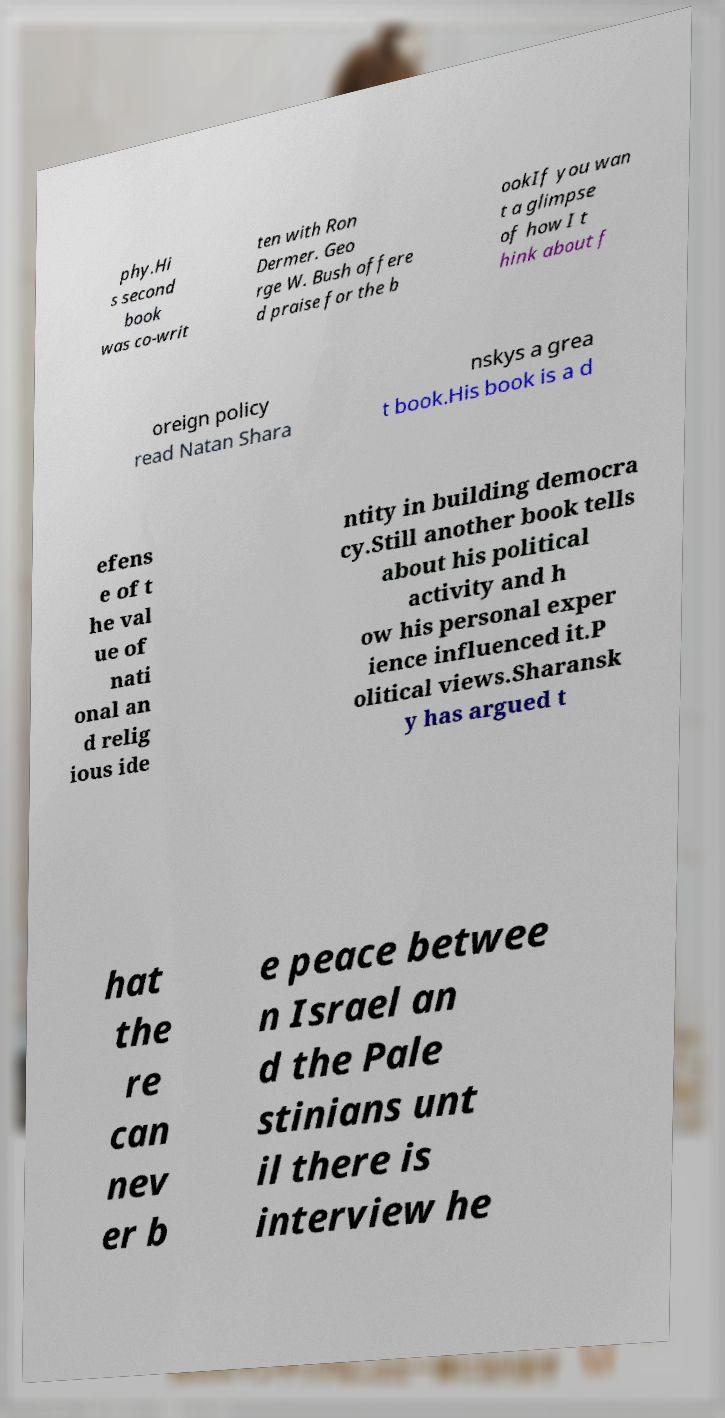Please read and relay the text visible in this image. What does it say? phy.Hi s second book was co-writ ten with Ron Dermer. Geo rge W. Bush offere d praise for the b ookIf you wan t a glimpse of how I t hink about f oreign policy read Natan Shara nskys a grea t book.His book is a d efens e of t he val ue of nati onal an d relig ious ide ntity in building democra cy.Still another book tells about his political activity and h ow his personal exper ience influenced it.P olitical views.Sharansk y has argued t hat the re can nev er b e peace betwee n Israel an d the Pale stinians unt il there is interview he 